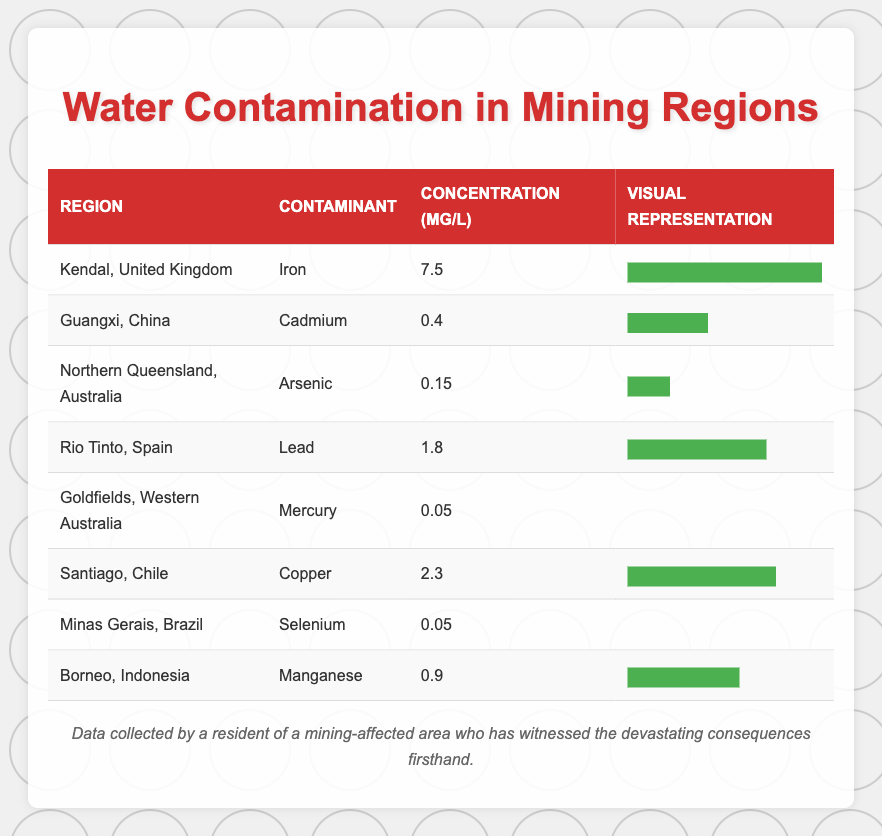What is the highest concentration of contamination observed in the table? The table shows various contamination levels across different regions. The highest value is listed under Kendal, United Kingdom with a concentration of 7.5 mg/L for Iron.
Answer: 7.5 mg/L Which region has the lowest concentration of water contamination? In the table, both Goldfields, Western Australia and Minas Gerais, Brazil have a concentration of 0.05 mg/L for Mercury and Selenium respectively. So, there are two regions with the same lowest concentration.
Answer: Goldfields, Western Australia and Minas Gerais, Brazil What contaminant has the highest concentration among all listed regions? From the table, Iron has the highest concentration at 7.5 mg/L in Kendal, United Kingdom. No other contaminant exceeds this level.
Answer: Iron Calculate the average concentration of contaminants in the regions listed. To find the average concentration, we add all the concentrations (7.5 + 0.4 + 0.15 + 1.8 + 0.05 + 2.3 + 0.05 + 0.9 = 12.15 mg/L) and divide by the number of regions, which is 8: 12.15 mg/L / 8 = 1.51875 mg/L. Rounding gives us approximately 1.52 mg/L.
Answer: 1.52 mg/L Is the concentration of Cadmium in Guangxi, China greater than that of Lead in Rio Tinto, Spain? The table states that the concentration of Cadmium in Guangxi is 0.4 mg/L while Lead in Rio Tinto has a concentration of 1.8 mg/L. Thus, Cadmium is less than Lead.
Answer: No Which two regions have concentrations that differ the most? The highest concentration is 7.5 mg/L (Kendal, United Kingdom) and the lowest is 0.05 mg/L (both Goldfields, Australia and Minas Gerais, Brazil). To find the difference: 7.5 mg/L - 0.05 mg/L = 7.45 mg/L. This is the largest difference between any two regions.
Answer: 7.45 mg/L Does Santiago, Chile have a higher concentration of contamination than Borneo, Indonesia? Santiago has a concentration of 2.3 mg/L for Copper while Borneo has 0.9 mg/L for Manganese. Thus, Santiago does have a higher concentration than Borneo.
Answer: Yes What is the visual representation of the concentration for Mercury? In the table, the visual representation of Mercury's concentration (0.05 mg/L) is shown with a concentration bar that represents 20% of the maximum width, indicating it has a comparatively low concentration.
Answer: 20% 